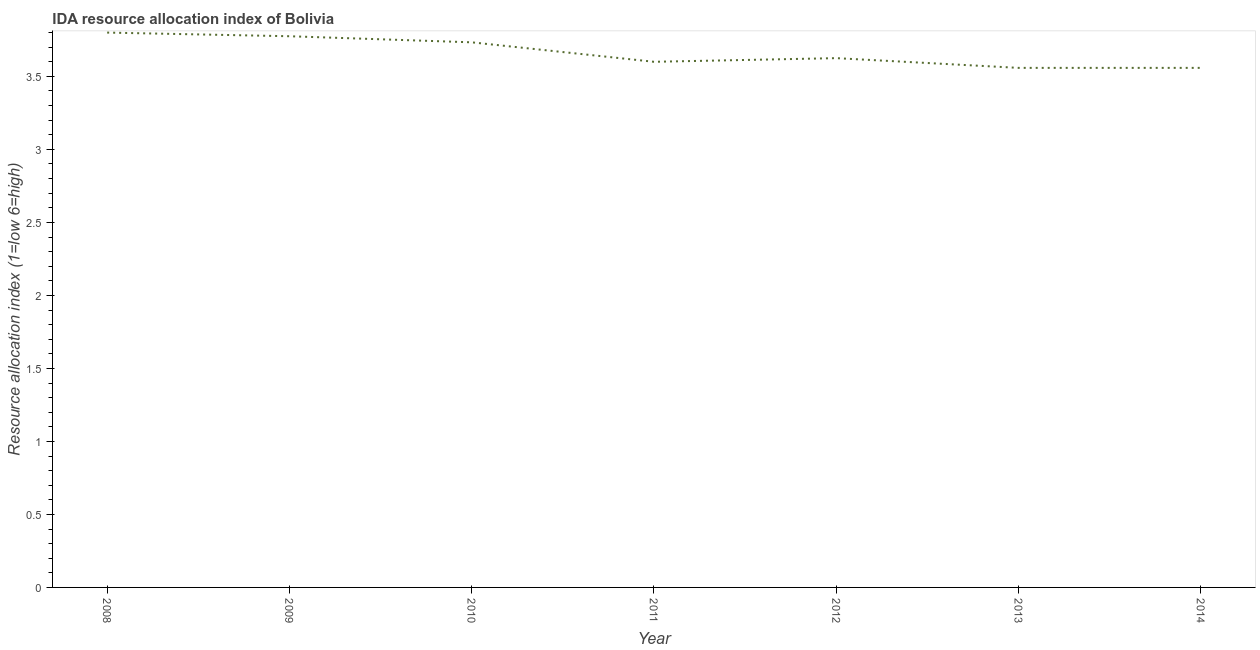Across all years, what is the minimum ida resource allocation index?
Your response must be concise. 3.56. In which year was the ida resource allocation index maximum?
Give a very brief answer. 2008. In which year was the ida resource allocation index minimum?
Your answer should be very brief. 2014. What is the sum of the ida resource allocation index?
Offer a very short reply. 25.65. What is the difference between the ida resource allocation index in 2010 and 2013?
Your answer should be compact. 0.17. What is the average ida resource allocation index per year?
Offer a terse response. 3.66. What is the median ida resource allocation index?
Provide a short and direct response. 3.62. In how many years, is the ida resource allocation index greater than 3.2 ?
Ensure brevity in your answer.  7. Do a majority of the years between 2010 and 2014 (inclusive) have ida resource allocation index greater than 3.4 ?
Your answer should be compact. Yes. What is the ratio of the ida resource allocation index in 2011 to that in 2014?
Give a very brief answer. 1.01. Is the difference between the ida resource allocation index in 2008 and 2010 greater than the difference between any two years?
Ensure brevity in your answer.  No. What is the difference between the highest and the second highest ida resource allocation index?
Your response must be concise. 0.02. What is the difference between the highest and the lowest ida resource allocation index?
Ensure brevity in your answer.  0.24. In how many years, is the ida resource allocation index greater than the average ida resource allocation index taken over all years?
Your answer should be very brief. 3. Does the ida resource allocation index monotonically increase over the years?
Your response must be concise. No. How many lines are there?
Give a very brief answer. 1. How many years are there in the graph?
Offer a very short reply. 7. Are the values on the major ticks of Y-axis written in scientific E-notation?
Ensure brevity in your answer.  No. What is the title of the graph?
Offer a terse response. IDA resource allocation index of Bolivia. What is the label or title of the X-axis?
Provide a succinct answer. Year. What is the label or title of the Y-axis?
Give a very brief answer. Resource allocation index (1=low 6=high). What is the Resource allocation index (1=low 6=high) of 2009?
Your answer should be compact. 3.77. What is the Resource allocation index (1=low 6=high) of 2010?
Ensure brevity in your answer.  3.73. What is the Resource allocation index (1=low 6=high) in 2011?
Provide a short and direct response. 3.6. What is the Resource allocation index (1=low 6=high) of 2012?
Your answer should be very brief. 3.62. What is the Resource allocation index (1=low 6=high) in 2013?
Your response must be concise. 3.56. What is the Resource allocation index (1=low 6=high) of 2014?
Your answer should be compact. 3.56. What is the difference between the Resource allocation index (1=low 6=high) in 2008 and 2009?
Offer a very short reply. 0.03. What is the difference between the Resource allocation index (1=low 6=high) in 2008 and 2010?
Keep it short and to the point. 0.07. What is the difference between the Resource allocation index (1=low 6=high) in 2008 and 2012?
Ensure brevity in your answer.  0.17. What is the difference between the Resource allocation index (1=low 6=high) in 2008 and 2013?
Provide a short and direct response. 0.24. What is the difference between the Resource allocation index (1=low 6=high) in 2008 and 2014?
Your answer should be compact. 0.24. What is the difference between the Resource allocation index (1=low 6=high) in 2009 and 2010?
Your response must be concise. 0.04. What is the difference between the Resource allocation index (1=low 6=high) in 2009 and 2011?
Ensure brevity in your answer.  0.17. What is the difference between the Resource allocation index (1=low 6=high) in 2009 and 2012?
Make the answer very short. 0.15. What is the difference between the Resource allocation index (1=low 6=high) in 2009 and 2013?
Make the answer very short. 0.22. What is the difference between the Resource allocation index (1=low 6=high) in 2009 and 2014?
Offer a very short reply. 0.22. What is the difference between the Resource allocation index (1=low 6=high) in 2010 and 2011?
Your answer should be compact. 0.13. What is the difference between the Resource allocation index (1=low 6=high) in 2010 and 2012?
Your response must be concise. 0.11. What is the difference between the Resource allocation index (1=low 6=high) in 2010 and 2013?
Give a very brief answer. 0.17. What is the difference between the Resource allocation index (1=low 6=high) in 2010 and 2014?
Provide a short and direct response. 0.17. What is the difference between the Resource allocation index (1=low 6=high) in 2011 and 2012?
Offer a very short reply. -0.03. What is the difference between the Resource allocation index (1=low 6=high) in 2011 and 2013?
Ensure brevity in your answer.  0.04. What is the difference between the Resource allocation index (1=low 6=high) in 2011 and 2014?
Your response must be concise. 0.04. What is the difference between the Resource allocation index (1=low 6=high) in 2012 and 2013?
Your answer should be very brief. 0.07. What is the difference between the Resource allocation index (1=low 6=high) in 2012 and 2014?
Offer a terse response. 0.07. What is the difference between the Resource allocation index (1=low 6=high) in 2013 and 2014?
Offer a terse response. 0. What is the ratio of the Resource allocation index (1=low 6=high) in 2008 to that in 2009?
Offer a terse response. 1.01. What is the ratio of the Resource allocation index (1=low 6=high) in 2008 to that in 2010?
Ensure brevity in your answer.  1.02. What is the ratio of the Resource allocation index (1=low 6=high) in 2008 to that in 2011?
Offer a very short reply. 1.06. What is the ratio of the Resource allocation index (1=low 6=high) in 2008 to that in 2012?
Your answer should be compact. 1.05. What is the ratio of the Resource allocation index (1=low 6=high) in 2008 to that in 2013?
Offer a very short reply. 1.07. What is the ratio of the Resource allocation index (1=low 6=high) in 2008 to that in 2014?
Your answer should be very brief. 1.07. What is the ratio of the Resource allocation index (1=low 6=high) in 2009 to that in 2011?
Offer a terse response. 1.05. What is the ratio of the Resource allocation index (1=low 6=high) in 2009 to that in 2012?
Your answer should be compact. 1.04. What is the ratio of the Resource allocation index (1=low 6=high) in 2009 to that in 2013?
Your answer should be very brief. 1.06. What is the ratio of the Resource allocation index (1=low 6=high) in 2009 to that in 2014?
Give a very brief answer. 1.06. What is the ratio of the Resource allocation index (1=low 6=high) in 2010 to that in 2013?
Offer a very short reply. 1.05. What is the ratio of the Resource allocation index (1=low 6=high) in 2010 to that in 2014?
Make the answer very short. 1.05. What is the ratio of the Resource allocation index (1=low 6=high) in 2011 to that in 2012?
Offer a terse response. 0.99. What is the ratio of the Resource allocation index (1=low 6=high) in 2011 to that in 2013?
Your answer should be compact. 1.01. What is the ratio of the Resource allocation index (1=low 6=high) in 2012 to that in 2014?
Offer a terse response. 1.02. What is the ratio of the Resource allocation index (1=low 6=high) in 2013 to that in 2014?
Your answer should be compact. 1. 